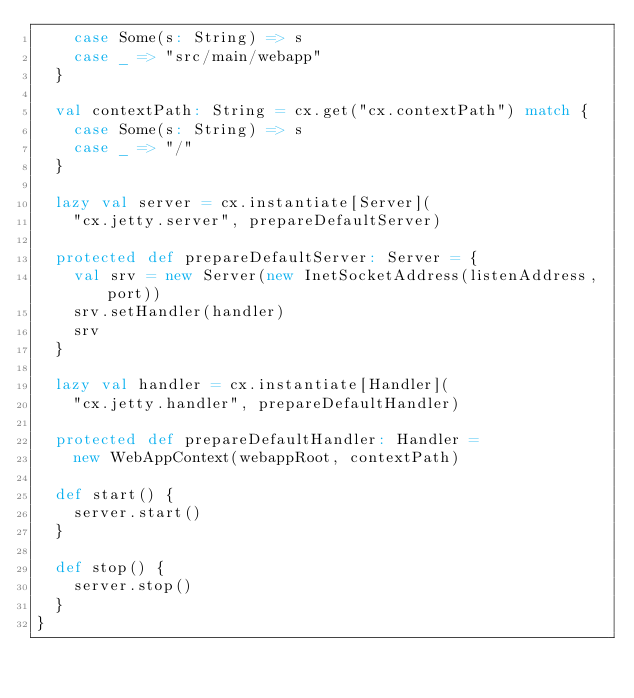<code> <loc_0><loc_0><loc_500><loc_500><_Scala_>    case Some(s: String) => s
    case _ => "src/main/webapp"
  }

  val contextPath: String = cx.get("cx.contextPath") match {
    case Some(s: String) => s
    case _ => "/"
  }

  lazy val server = cx.instantiate[Server](
    "cx.jetty.server", prepareDefaultServer)

  protected def prepareDefaultServer: Server = {
    val srv = new Server(new InetSocketAddress(listenAddress, port))
    srv.setHandler(handler)
    srv
  }

  lazy val handler = cx.instantiate[Handler](
    "cx.jetty.handler", prepareDefaultHandler)

  protected def prepareDefaultHandler: Handler =
    new WebAppContext(webappRoot, contextPath)

  def start() {
    server.start()
  }

  def stop() {
    server.stop()
  }
}
</code> 